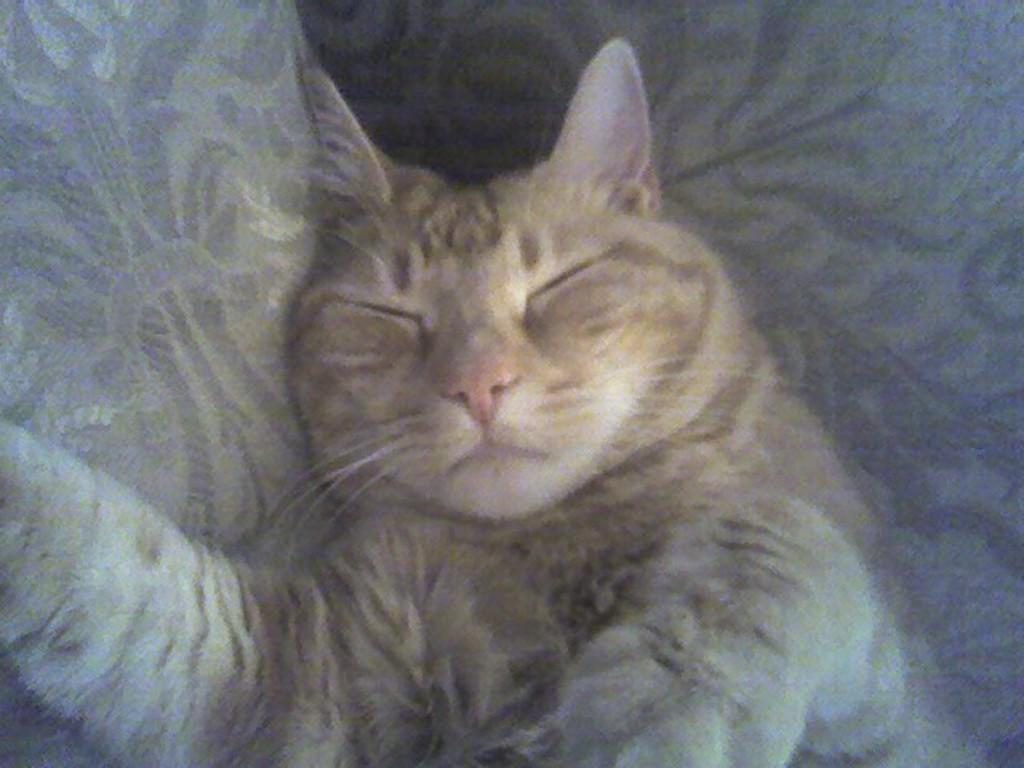What animal is present in the image? There is a cat in the image. Where is the cat located in the image? The cat is in the center of the image. What is the cat doing in the image? The cat seems to be sleeping. What is the cat resting on in the image? The cat is on an object. Can you see a bear pushing the cat in the image? No, there is no bear or pushing action present in the image. 